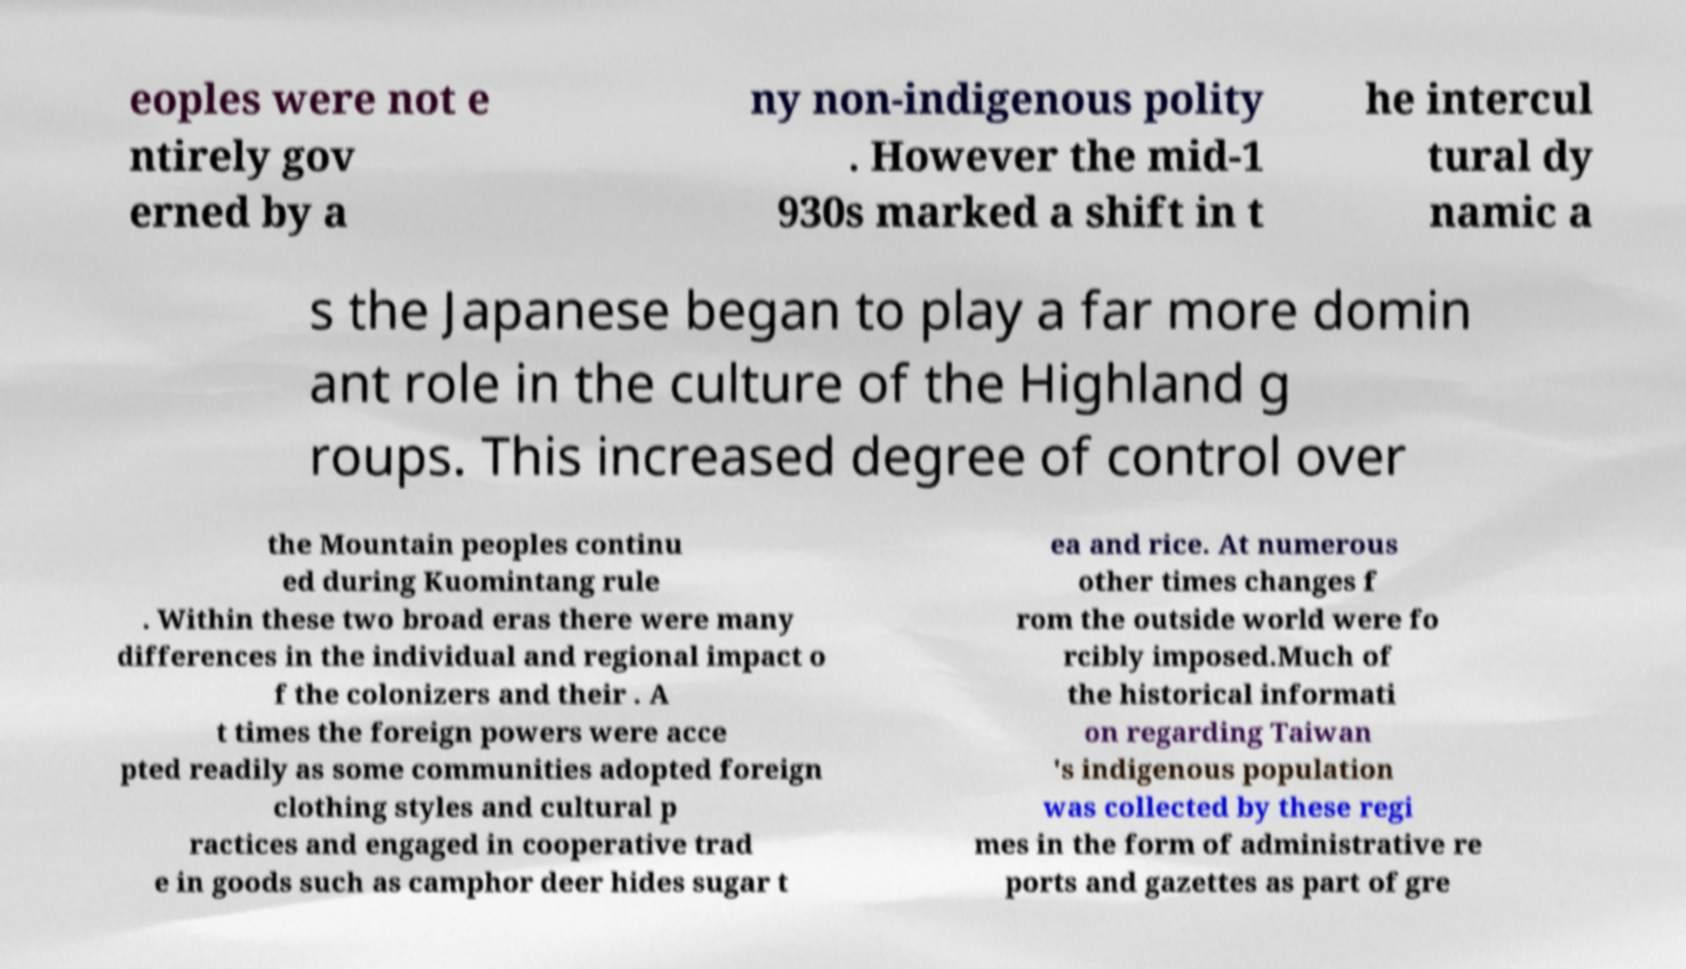Can you accurately transcribe the text from the provided image for me? eoples were not e ntirely gov erned by a ny non-indigenous polity . However the mid-1 930s marked a shift in t he intercul tural dy namic a s the Japanese began to play a far more domin ant role in the culture of the Highland g roups. This increased degree of control over the Mountain peoples continu ed during Kuomintang rule . Within these two broad eras there were many differences in the individual and regional impact o f the colonizers and their . A t times the foreign powers were acce pted readily as some communities adopted foreign clothing styles and cultural p ractices and engaged in cooperative trad e in goods such as camphor deer hides sugar t ea and rice. At numerous other times changes f rom the outside world were fo rcibly imposed.Much of the historical informati on regarding Taiwan 's indigenous population was collected by these regi mes in the form of administrative re ports and gazettes as part of gre 